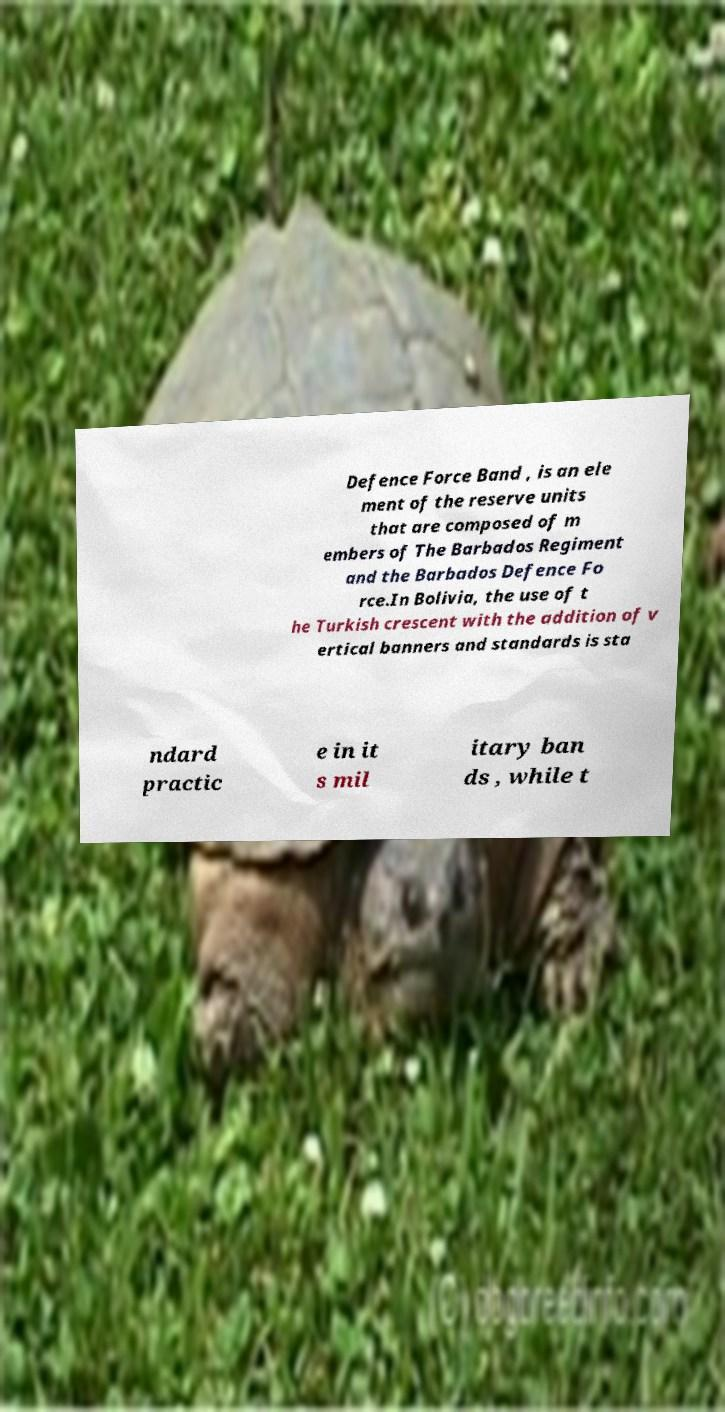For documentation purposes, I need the text within this image transcribed. Could you provide that? Defence Force Band , is an ele ment of the reserve units that are composed of m embers of The Barbados Regiment and the Barbados Defence Fo rce.In Bolivia, the use of t he Turkish crescent with the addition of v ertical banners and standards is sta ndard practic e in it s mil itary ban ds , while t 